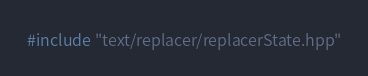<code> <loc_0><loc_0><loc_500><loc_500><_C++_>#include "text/replacer/replacerState.hpp"</code> 